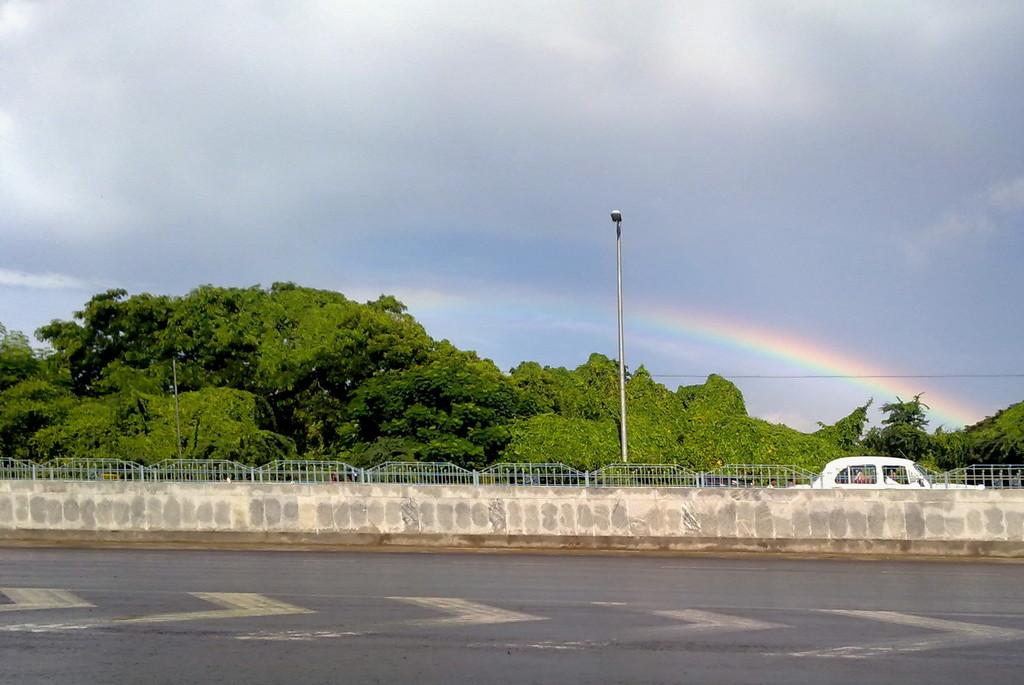What is the main subject of the image? There is a vehicle in the image. Can you describe the color of the vehicle? The vehicle is white. What can be seen in the background of the image? There are trees, a light pole, and a rainbow visible in the background of the image. What color are the trees in the background? The trees are green. How would you describe the sky in the image? A: The sky is white and gray in color. What type of stone can be seen in the aftermath of the vehicle's collision in the image? There is no collision or stone present in the image; it features a vehicle with a background of trees, a light pole, and a rainbow. What kind of boot is the person wearing while standing next to the vehicle in the image? There is no person or boot visible in the image; it only shows a vehicle and the background elements. 